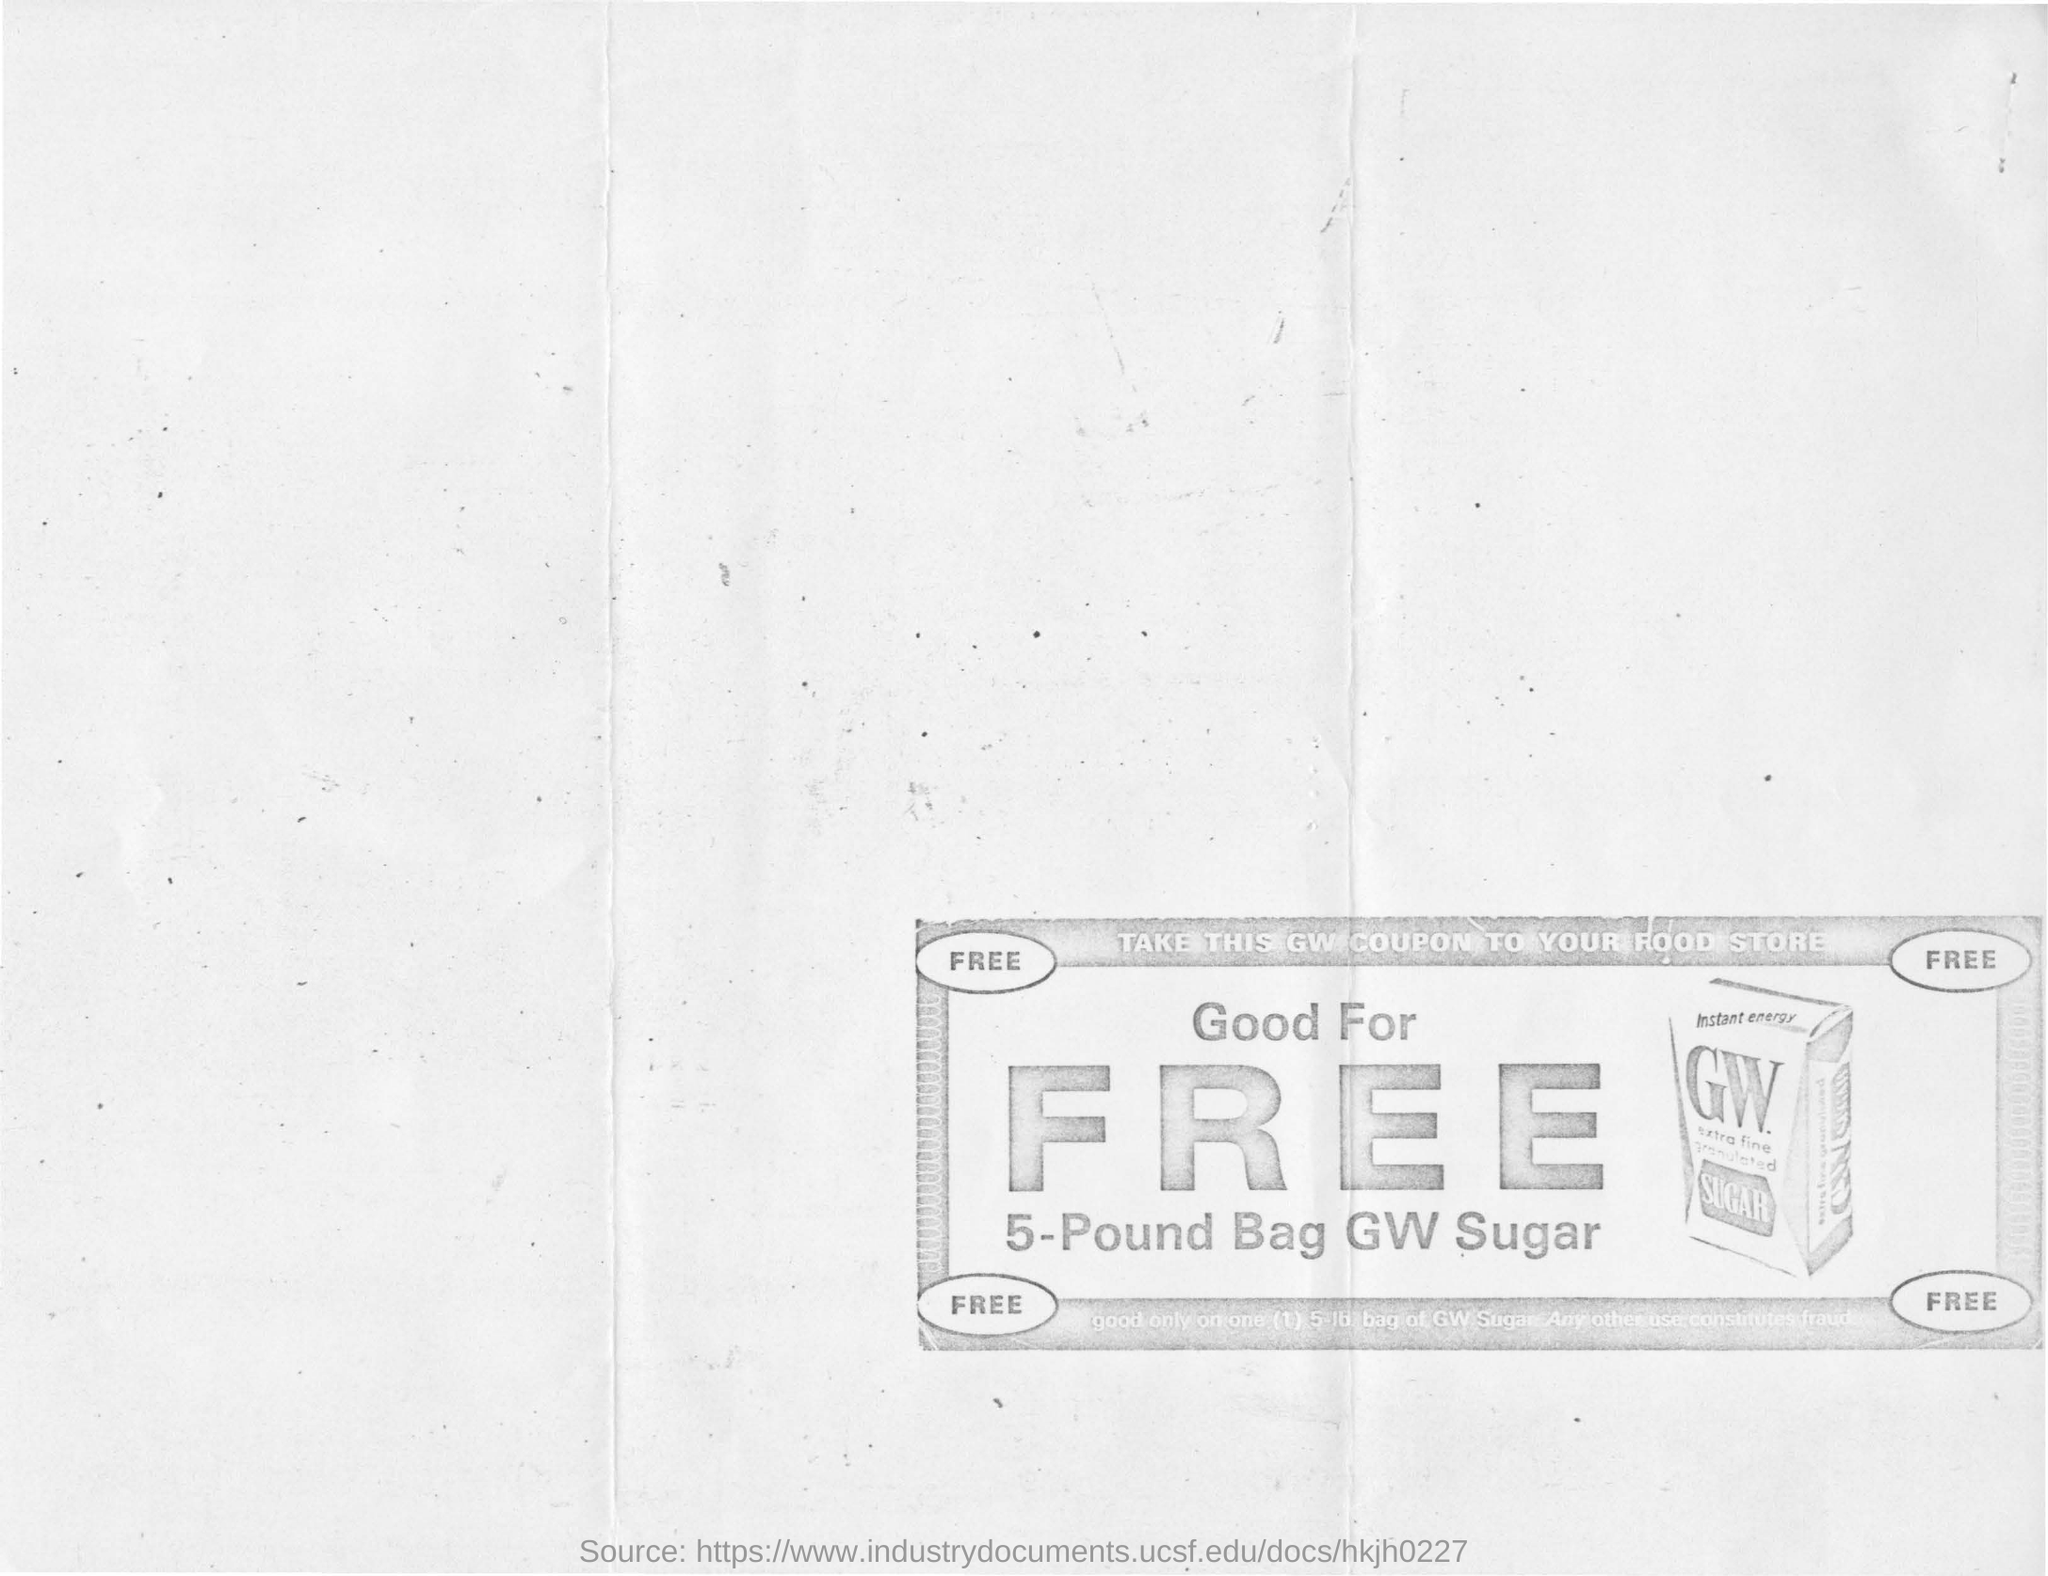How much of sugar is being given for free?
Provide a succinct answer. 5-Pound. What is the name of the company?
Keep it short and to the point. GW. What is written lightly on the top of the coupon?
Your response must be concise. TAKE THIS GW COUPON TO YOUR FOOD STORE. 